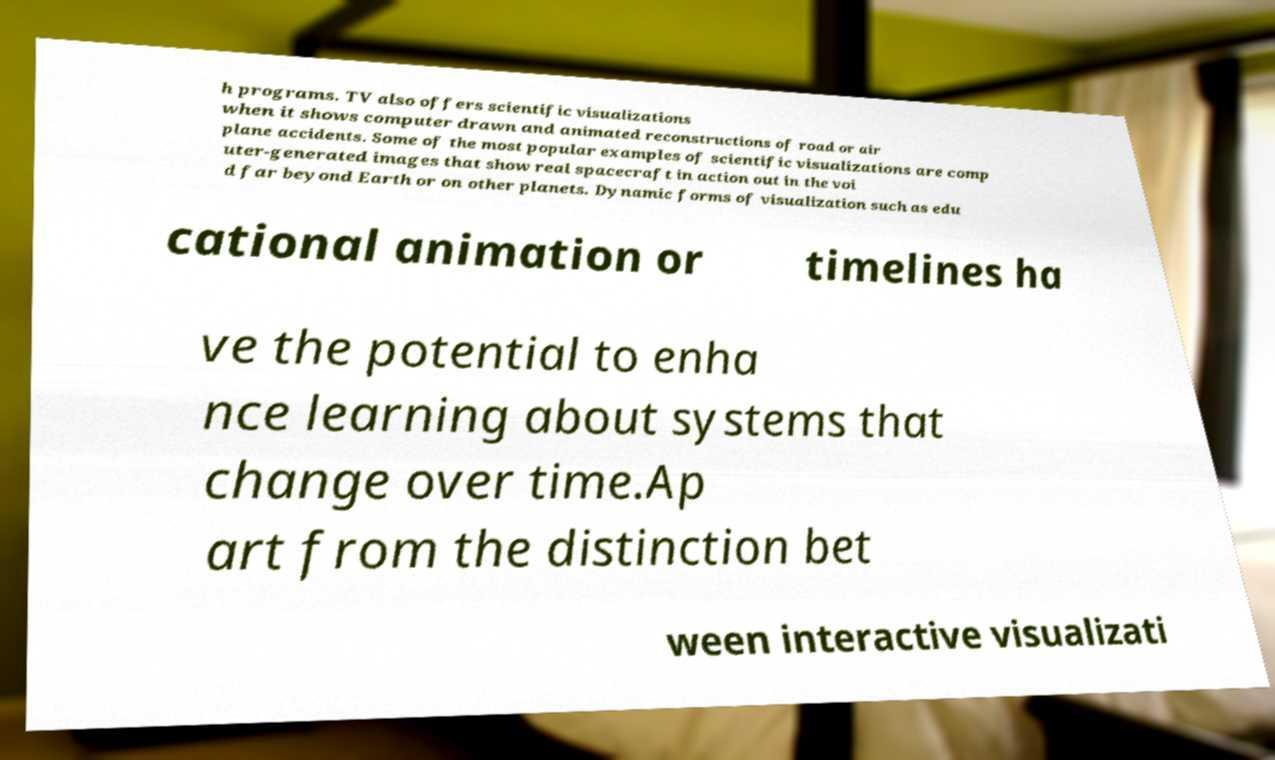Can you accurately transcribe the text from the provided image for me? h programs. TV also offers scientific visualizations when it shows computer drawn and animated reconstructions of road or air plane accidents. Some of the most popular examples of scientific visualizations are comp uter-generated images that show real spacecraft in action out in the voi d far beyond Earth or on other planets. Dynamic forms of visualization such as edu cational animation or timelines ha ve the potential to enha nce learning about systems that change over time.Ap art from the distinction bet ween interactive visualizati 